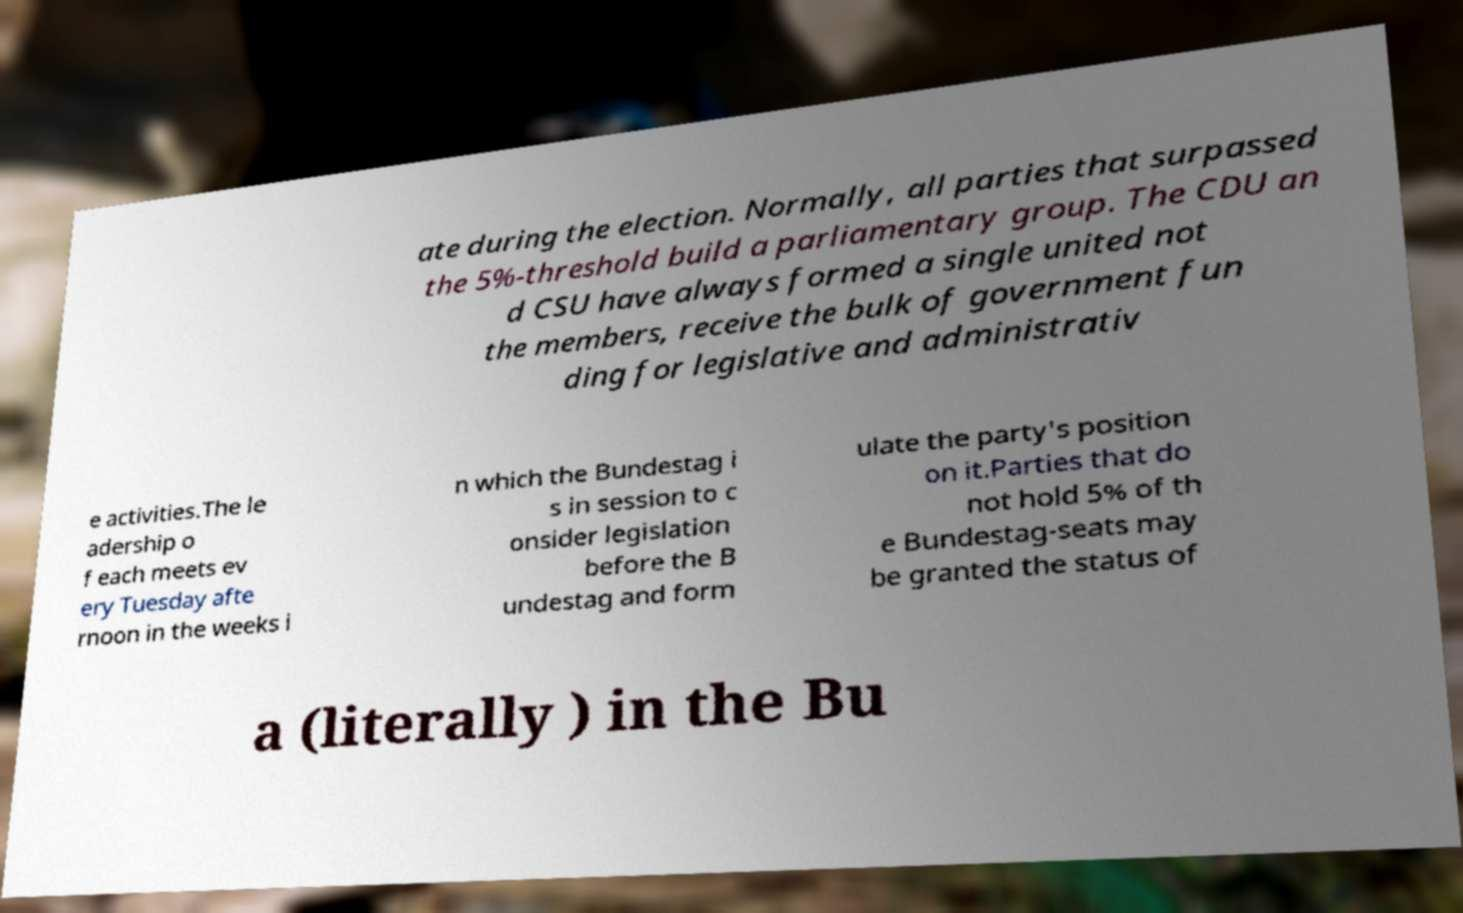Can you accurately transcribe the text from the provided image for me? ate during the election. Normally, all parties that surpassed the 5%-threshold build a parliamentary group. The CDU an d CSU have always formed a single united not the members, receive the bulk of government fun ding for legislative and administrativ e activities.The le adership o f each meets ev ery Tuesday afte rnoon in the weeks i n which the Bundestag i s in session to c onsider legislation before the B undestag and form ulate the party's position on it.Parties that do not hold 5% of th e Bundestag-seats may be granted the status of a (literally ) in the Bu 